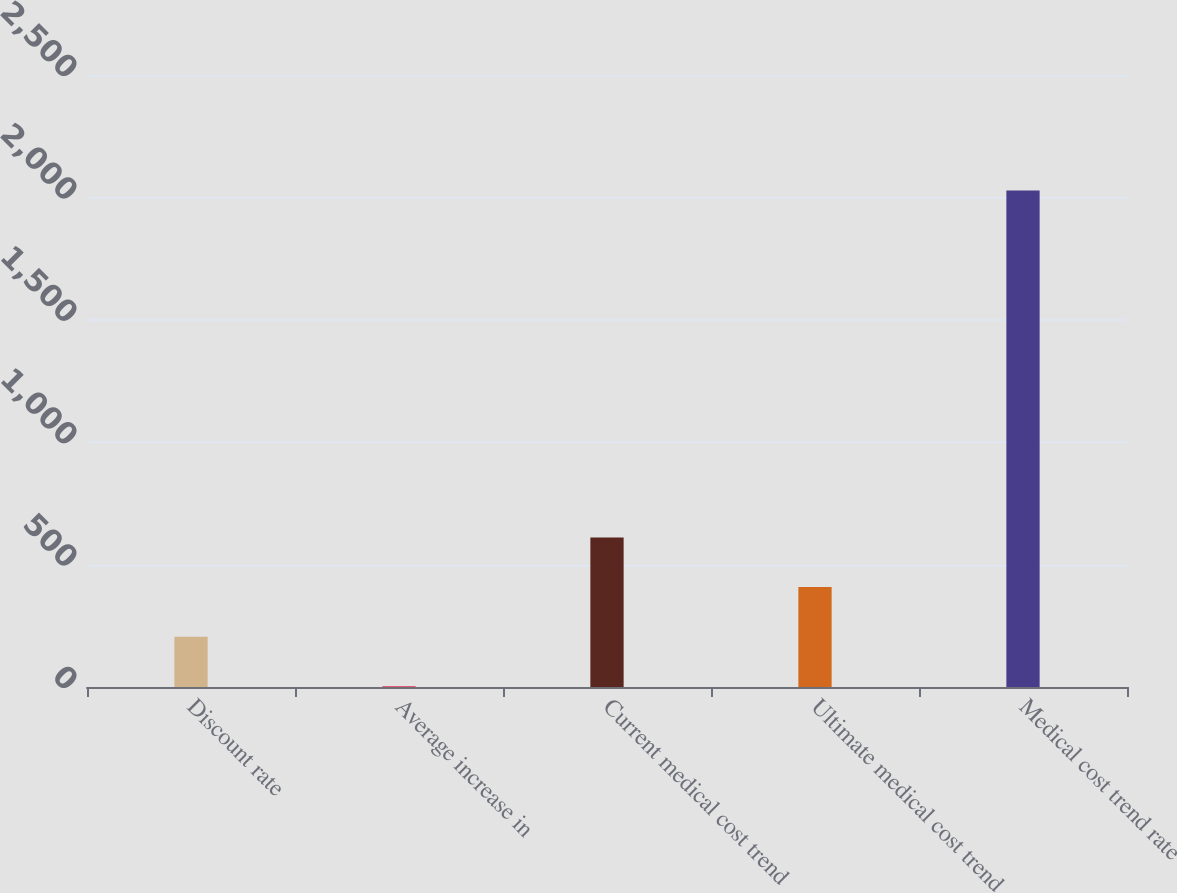Convert chart. <chart><loc_0><loc_0><loc_500><loc_500><bar_chart><fcel>Discount rate<fcel>Average increase in<fcel>Current medical cost trend<fcel>Ultimate medical cost trend<fcel>Medical cost trend rate<nl><fcel>205.5<fcel>3<fcel>610.5<fcel>408<fcel>2028<nl></chart> 